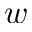Convert formula to latex. <formula><loc_0><loc_0><loc_500><loc_500>w</formula> 